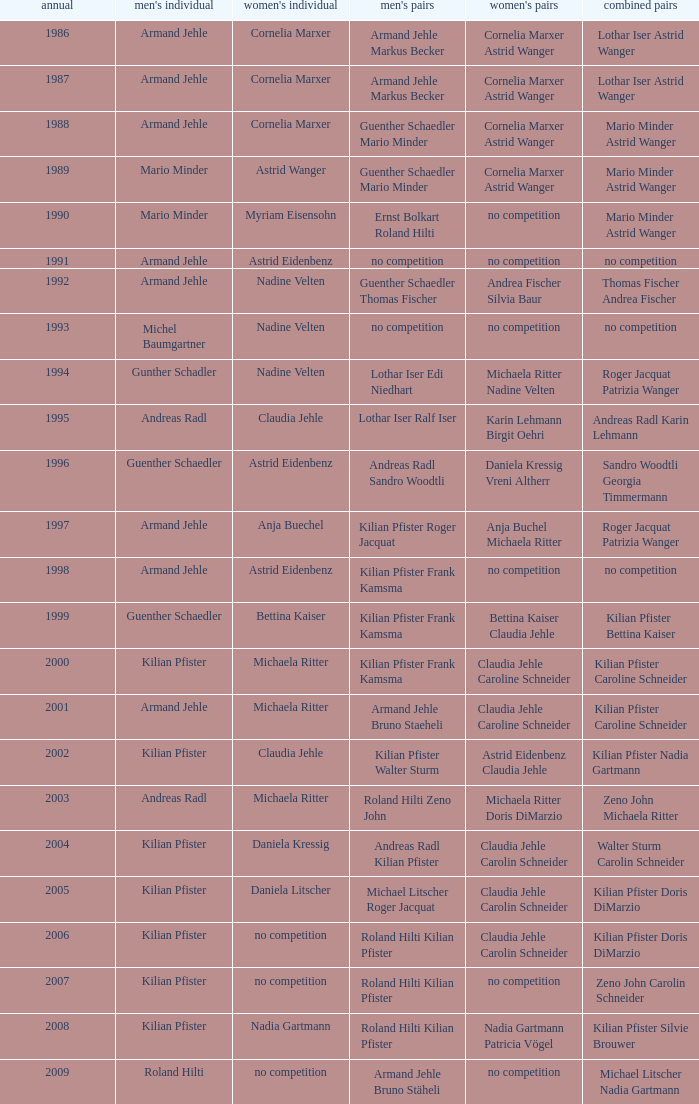In 1987 who was the mens singles Armand Jehle. 